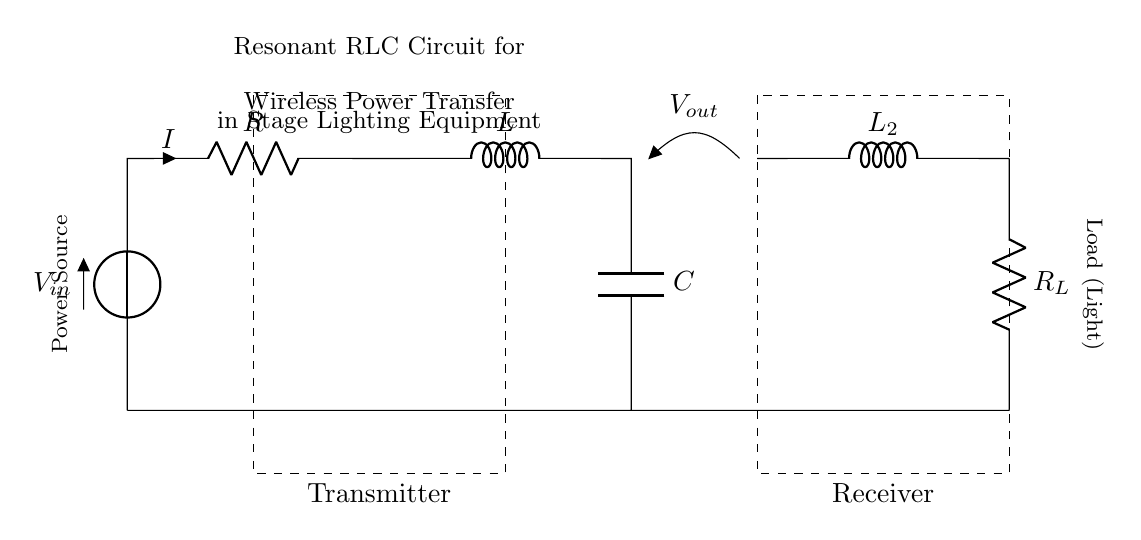What is the function of the inductor in this circuit? The inductor stores energy in its magnetic field when current flows through it, contributing to the resonant behavior of the circuit.
Answer: energy storage What are the components visible in the transmitter portion of the circuit? The transmitter consists of a voltage source, resistor, inductor, and capacitor. These elements work together to convert electrical energy into a resonant oscillation for power transfer.
Answer: voltage source, resistor, inductor, capacitor What is the load connected to in the receiving section? The load is connected to the resonant circuit through a resistor, which represents the light that needs to be powered in this application.
Answer: resistor What is the effect of resonance in this RLC circuit? Resonance occurs when the inductive reactance and capacitive reactance are equal, allowing for maximum energy transfer and efficient power delivery to the load.
Answer: maximum energy transfer What happens to the current in this circuit at resonance? At resonance, the total impedance of the circuit is minimized, and the current peaks, leading to maximum power transfer to the load.
Answer: current peaks What type of circuit is depicted in the diagram? This is a resonant RLC circuit designed for wireless power transfer applications, specifically in stage lighting equipment.
Answer: resonant RLC circuit 